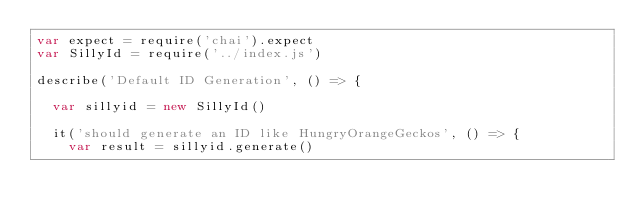<code> <loc_0><loc_0><loc_500><loc_500><_JavaScript_>var expect = require('chai').expect
var SillyId = require('../index.js')

describe('Default ID Generation', () => {

  var sillyid = new SillyId()

  it('should generate an ID like HungryOrangeGeckos', () => {
    var result = sillyid.generate()</code> 